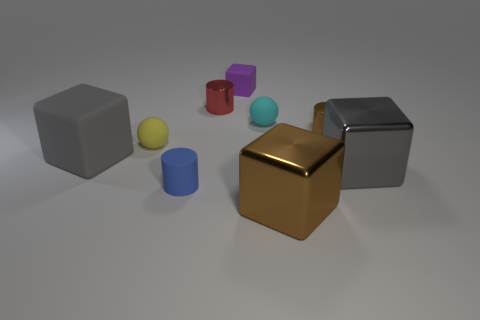Subtract all large gray matte cubes. How many cubes are left? 3 Subtract 1 spheres. How many spheres are left? 1 Subtract all yellow spheres. How many spheres are left? 1 Add 1 green blocks. How many objects exist? 10 Subtract all blue balls. How many gray cubes are left? 2 Subtract all tiny blue cylinders. Subtract all tiny blue matte cylinders. How many objects are left? 7 Add 8 tiny purple objects. How many tiny purple objects are left? 9 Add 4 blue cylinders. How many blue cylinders exist? 5 Subtract 0 cyan cubes. How many objects are left? 9 Subtract all cylinders. How many objects are left? 6 